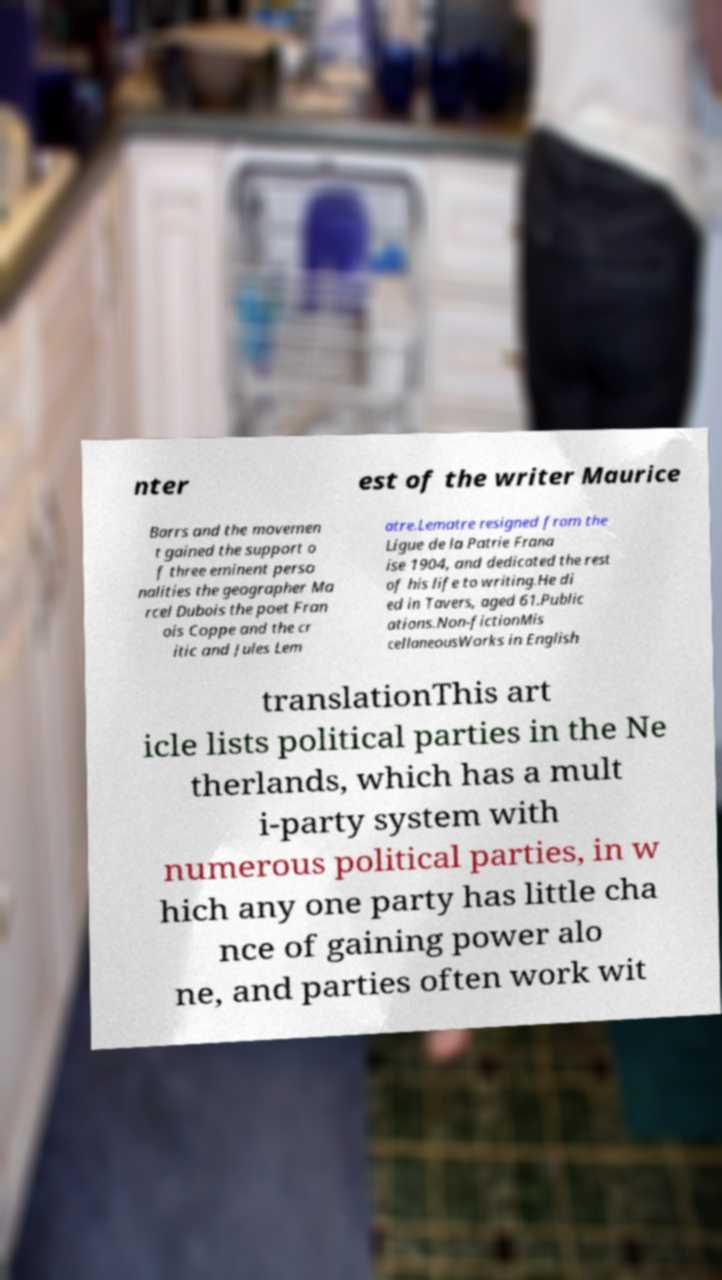Could you extract and type out the text from this image? nter est of the writer Maurice Barrs and the movemen t gained the support o f three eminent perso nalities the geographer Ma rcel Dubois the poet Fran ois Coppe and the cr itic and Jules Lem atre.Lematre resigned from the Ligue de la Patrie Frana ise 1904, and dedicated the rest of his life to writing.He di ed in Tavers, aged 61.Public ations.Non-fictionMis cellaneousWorks in English translationThis art icle lists political parties in the Ne therlands, which has a mult i-party system with numerous political parties, in w hich any one party has little cha nce of gaining power alo ne, and parties often work wit 